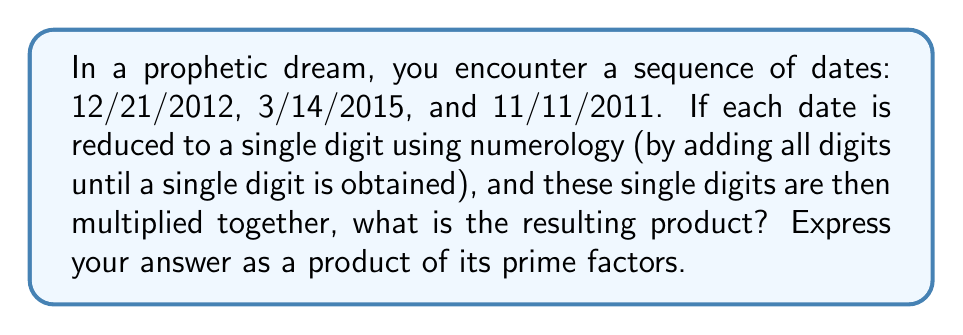Solve this math problem. To solve this problem, we'll follow these steps:

1. Reduce each date to a single digit using numerology:

   a) 12/21/2012: $1+2+2+1+2+0+1+2 = 11$, then $1+1 = 2$
   b) 3/14/2015: $3+1+4+2+0+1+5 = 16$, then $1+6 = 7$
   c) 11/11/2011: $1+1+1+1+2+0+1+1 = 8$

2. Multiply the resulting single digits:

   $2 \times 7 \times 8 = 112$

3. Express 112 as a product of its prime factors:

   $112 = 2^4 \times 7$

   We can verify this:
   $2^4 = 16$
   $16 \times 7 = 112$

Thus, the final answer is $2^4 \times 7$.
Answer: $2^4 \times 7$ 